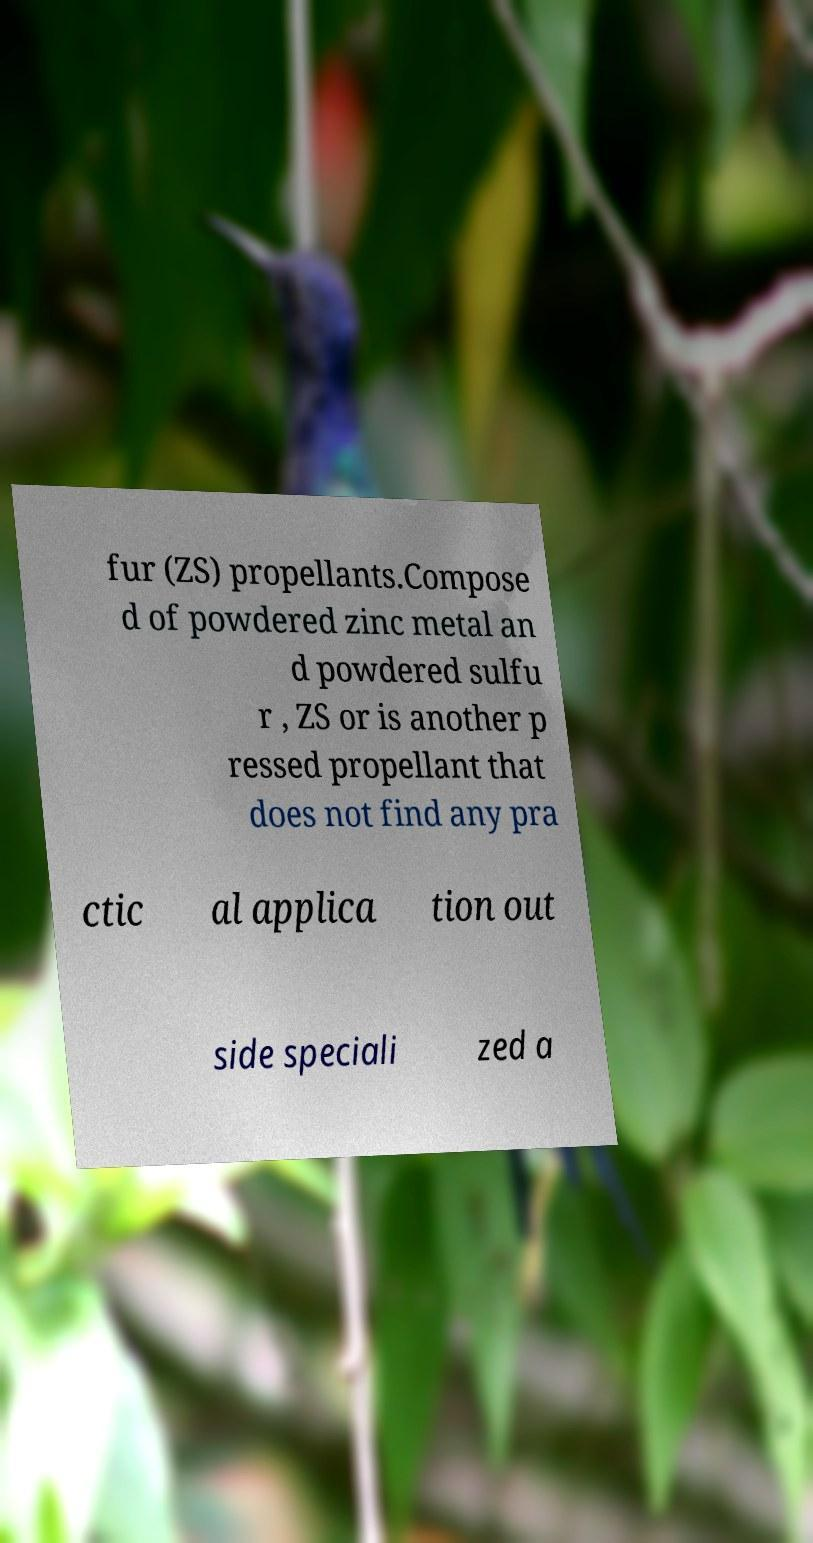Could you assist in decoding the text presented in this image and type it out clearly? fur (ZS) propellants.Compose d of powdered zinc metal an d powdered sulfu r , ZS or is another p ressed propellant that does not find any pra ctic al applica tion out side speciali zed a 